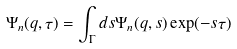Convert formula to latex. <formula><loc_0><loc_0><loc_500><loc_500>\Psi _ { n } ( q , \tau ) = \int _ { \Gamma } d s \Psi _ { n } ( q , s ) \exp ( - s \tau )</formula> 